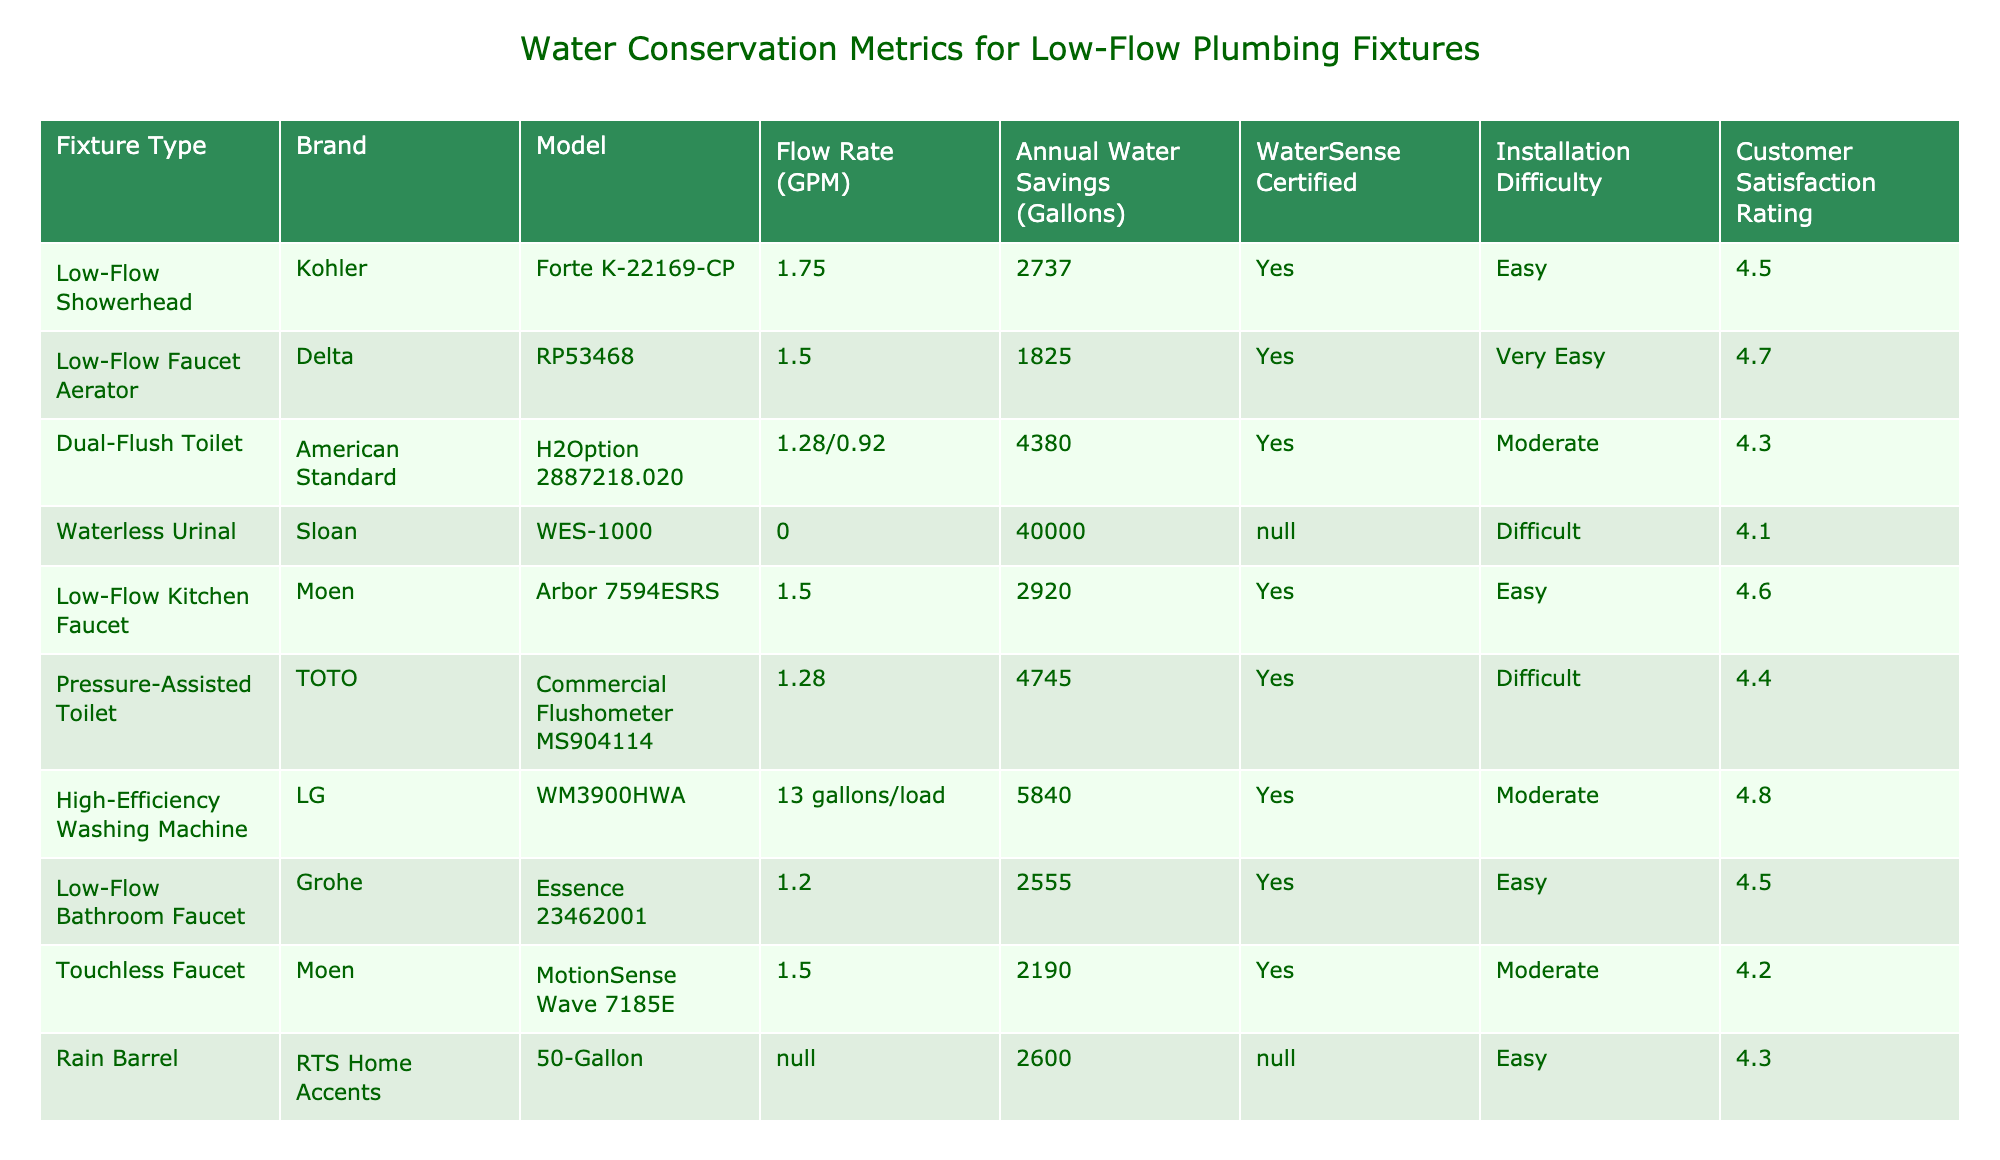What is the flow rate of the Kohler Forte K-22169-CP showerhead? The table lists the flow rate for the Kohler Forte K-22169-CP under the "Flow Rate (GPM)" column, which states it is 1.75 GPM.
Answer: 1.75 GPM Which fixture has the highest annual water savings? By comparing the values in the "Annual Water Savings (Gallons)" column, the Waterless Urinal by Sloan shows the highest savings at 40,000 gallons.
Answer: 40,000 gallons Is the Delta RP53468 faucet aerator WaterSense certified? The "WaterSense Certified" column indicates that the Delta RP53468 faucet aerator is marked as "Yes," confirming its certification.
Answer: Yes What is the difference in annual water savings between the Dual-Flush Toilet and the Pressure-Assisted Toilet? The Dual-Flush Toilet saves 4,380 gallons while the Pressure-Assisted Toilet saves 4,745 gallons. The difference is 4,745 - 4,380 = 365 gallons.
Answer: 365 gallons How many fixtures have a Customer Satisfaction Rating of 4.5 or higher? There are a total of 7 fixtures with Ratings of 4.5 or higher: the Kohler showerhead, Delta faucet aerator, Low-Flow kitchen faucet, Grohe bathroom faucet, and the High-Efficiency washing machine.
Answer: 5 fixtures What is the average flow rate of the Low-Flow showerheads listed in the table? The flow rates for the listed Low-Flow showerheads are 1.75 GPM (Kohler) and 1.2 GPM (Grohe). The average is (1.75 + 1.2) / 2 = 1.475 GPM.
Answer: 1.475 GPM Which brand offers a product that does not provide a flow rate? The table shows two products without a flow rate listed: the Waterless Urinal (Sloan) and the Greywater System (Aqua2use).
Answer: Sloan and Aqua2use What percentage of fixtures listed are WaterSense certified? There are 10 fixtures in total, and 7 are marked as WaterSense certified. The percentage is (7/10) * 100 = 70%.
Answer: 70% Which fixture has the highest Customer Satisfaction Rating? The High-Efficiency Washing Machine by LG has the highest rating at 4.8.
Answer: 4.8 How do the installation difficulties compare between the fixtures? Upon reviewing the "Installation Difficulty" column, we see that there are Easy, Very Easy, Moderate, and Difficult reflections. The majority (5 of 10) fixtures have either Easy or Very Easy installation.
Answer: Majority are Easy or Very Easy 